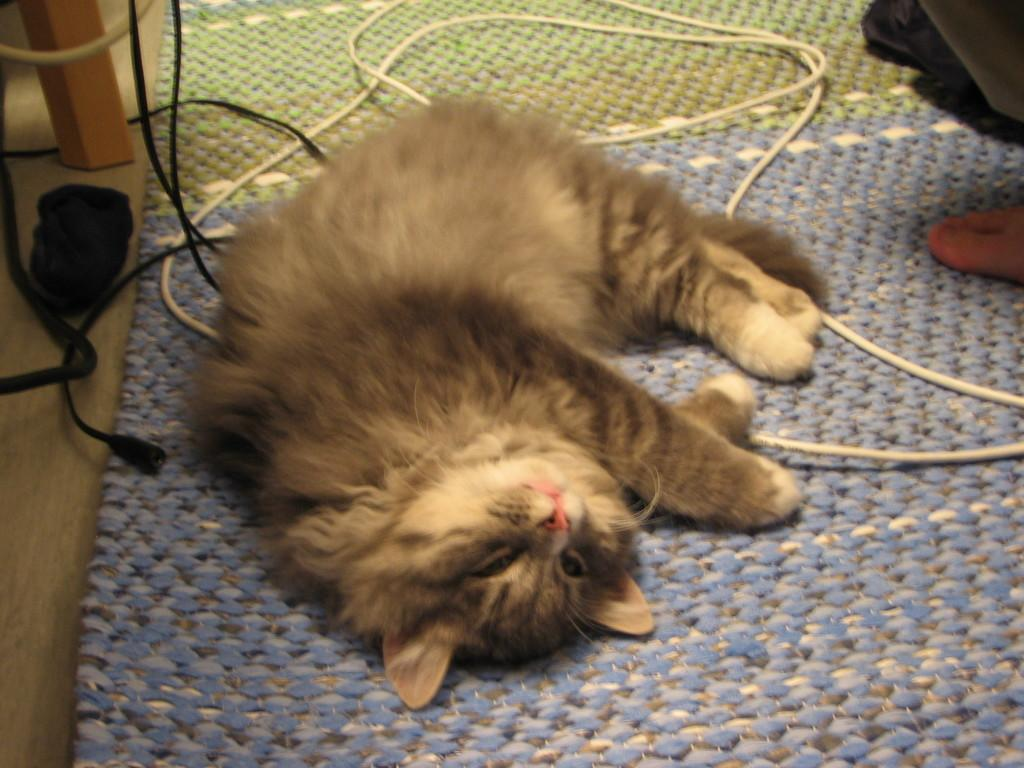What animal can be seen laying on a mat in the image? There is a cat laying on a mat in the image. What type of objects are visible in the image that are not related to the cat? Cables and a wooden object are visible in the image. Can you describe the person's foot that is present in the image? A person's foot is present on the right side of the image. What type of bait is being used to attract the bears in the image? There are no bears or bait present in the image; it features a cat laying on a mat, cables, a wooden object, and a person's foot. 